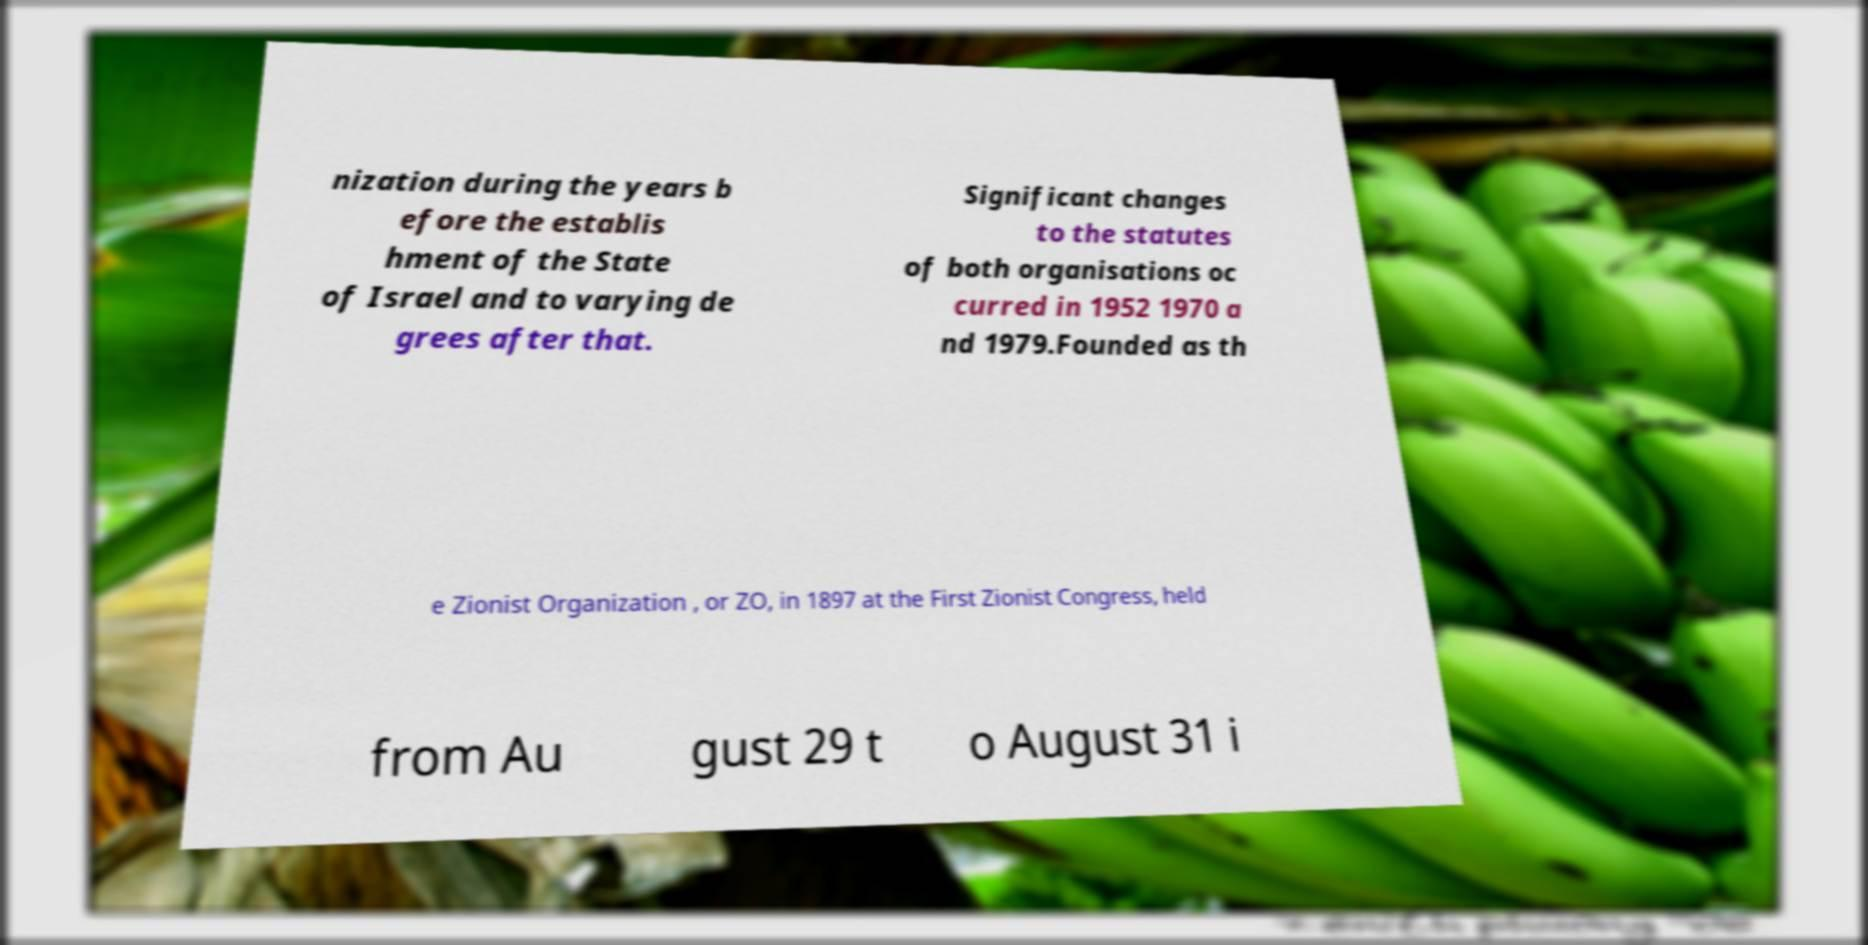I need the written content from this picture converted into text. Can you do that? nization during the years b efore the establis hment of the State of Israel and to varying de grees after that. Significant changes to the statutes of both organisations oc curred in 1952 1970 a nd 1979.Founded as th e Zionist Organization , or ZO, in 1897 at the First Zionist Congress, held from Au gust 29 t o August 31 i 